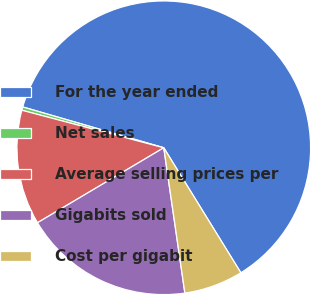Convert chart. <chart><loc_0><loc_0><loc_500><loc_500><pie_chart><fcel>For the year ended<fcel>Net sales<fcel>Average selling prices per<fcel>Gigabits sold<fcel>Cost per gigabit<nl><fcel>61.72%<fcel>0.37%<fcel>12.64%<fcel>18.77%<fcel>6.5%<nl></chart> 